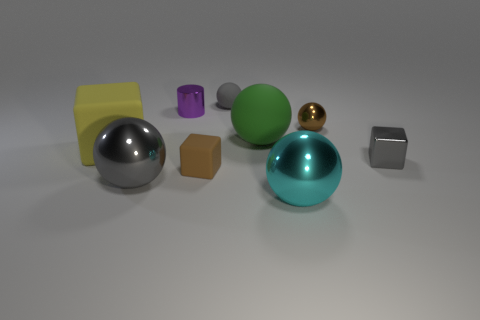How many cubes are either big yellow objects or cyan metal objects?
Keep it short and to the point. 1. Is the number of balls that are behind the yellow thing less than the number of large cyan shiny objects?
Ensure brevity in your answer.  No. What number of other objects are the same material as the small brown ball?
Provide a succinct answer. 4. Do the metallic cylinder and the brown cube have the same size?
Keep it short and to the point. Yes. How many things are objects in front of the tiny purple cylinder or small metallic blocks?
Your answer should be compact. 7. There is a tiny ball on the right side of the tiny gray object that is behind the small gray metallic object; what is it made of?
Provide a succinct answer. Metal. Are there any big blue shiny objects of the same shape as the big green thing?
Ensure brevity in your answer.  No. Do the gray matte object and the gray sphere in front of the tiny metallic cylinder have the same size?
Your answer should be compact. No. What number of objects are large shiny spheres that are left of the shiny cylinder or tiny rubber objects behind the brown metal sphere?
Make the answer very short. 2. Are there more matte spheres that are behind the tiny purple object than green blocks?
Your answer should be compact. Yes. 